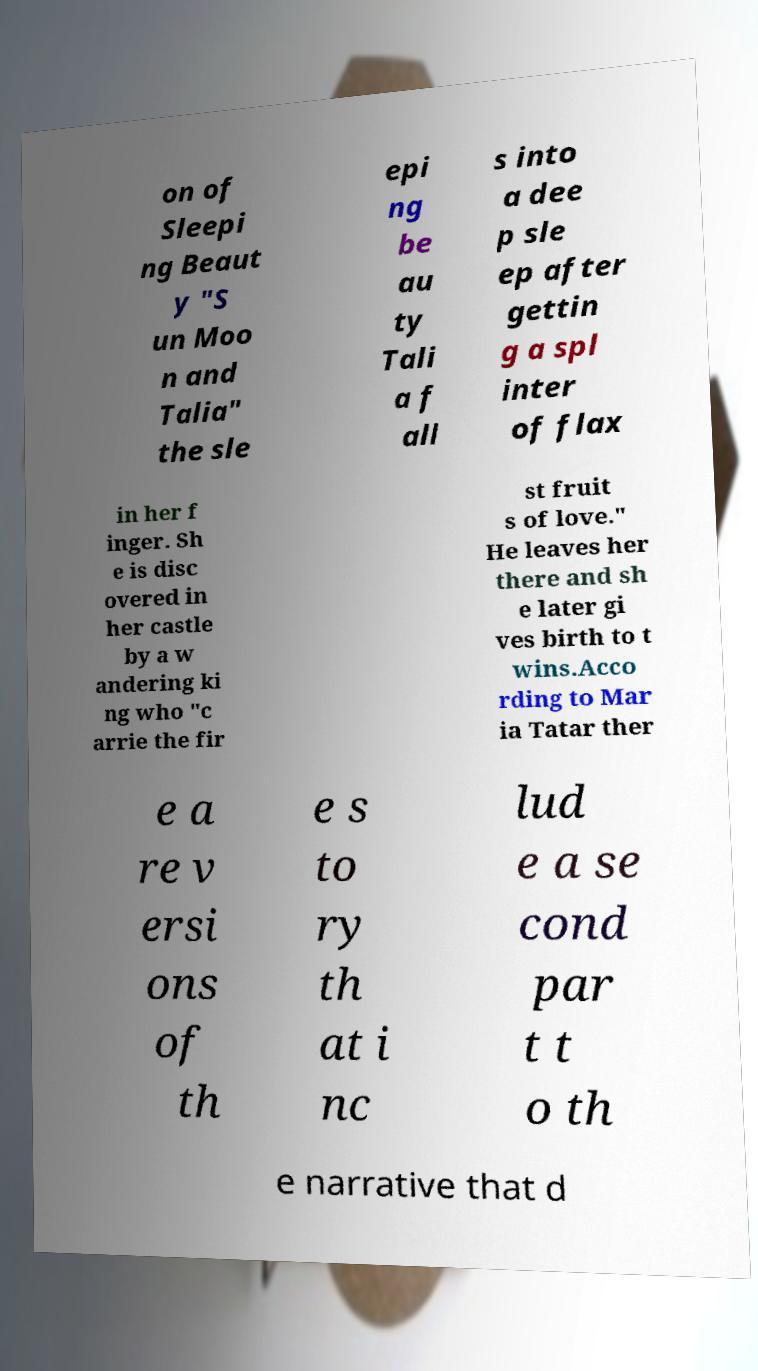Could you extract and type out the text from this image? on of Sleepi ng Beaut y "S un Moo n and Talia" the sle epi ng be au ty Tali a f all s into a dee p sle ep after gettin g a spl inter of flax in her f inger. Sh e is disc overed in her castle by a w andering ki ng who "c arrie the fir st fruit s of love." He leaves her there and sh e later gi ves birth to t wins.Acco rding to Mar ia Tatar ther e a re v ersi ons of th e s to ry th at i nc lud e a se cond par t t o th e narrative that d 